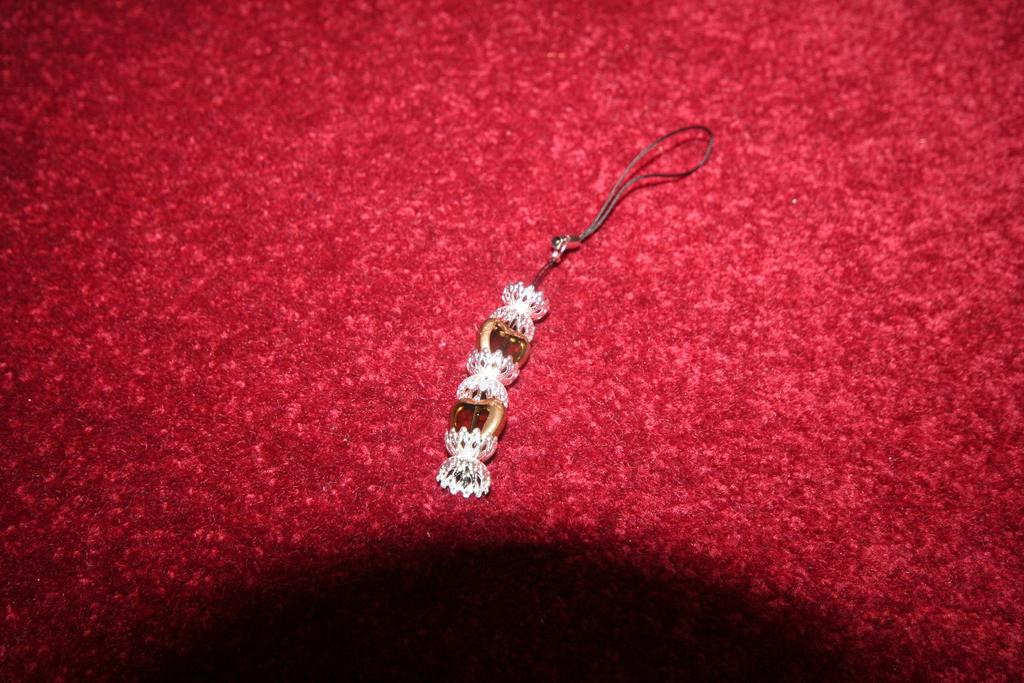What is the main subject of the image? There is a decorative object in the image. Where is the decorative object placed? The decorative object is on a cloth. What color is the cloth? The cloth is red in color. What time is the meeting scheduled for in the image? There is no mention of a meeting or time in the image; it features a decorative object on a red cloth. Can you describe the feather on the decorative object in the image? There is no feather present on the decorative object in the image. 